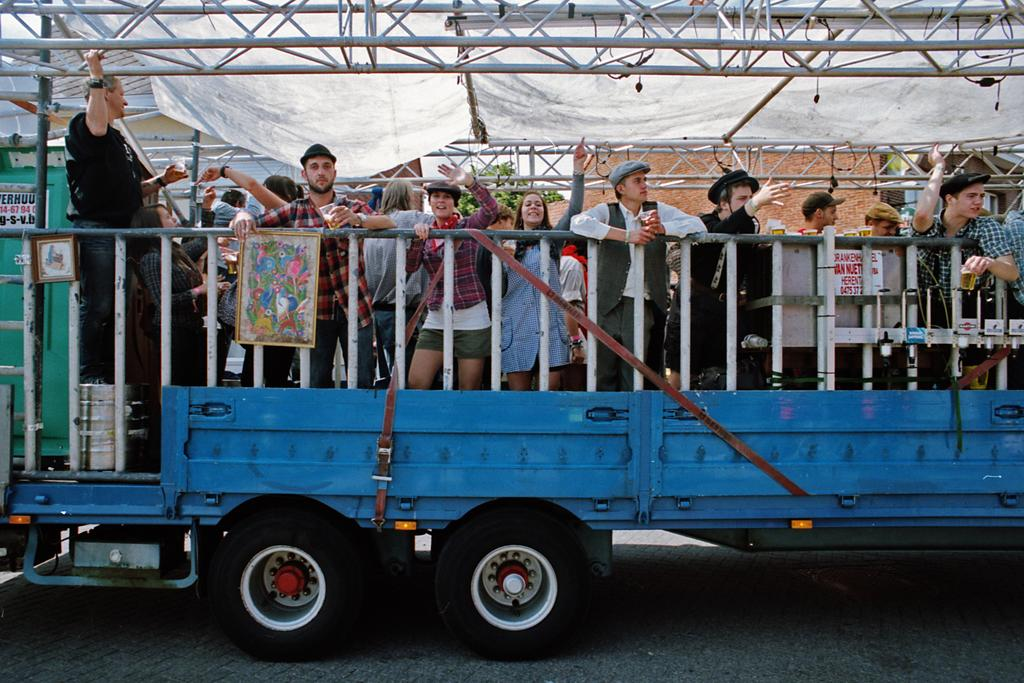What are the people in the image doing? The people in the image are standing on a truck. What is covering the people on the truck? There is cloth above the people on the truck. What can be seen in the background of the image? There is a wall in the background of the image. What is in front of the cloth in the image? There is a metal frame in front of the cloth. What is the purpose of the planes flying in the image? There are no planes visible in the image, so we cannot determine their purpose. 